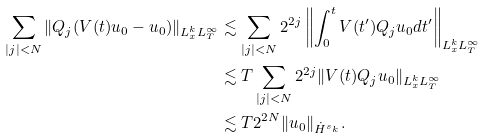<formula> <loc_0><loc_0><loc_500><loc_500>\sum _ { | j | < N } \| Q _ { j } ( V ( t ) u _ { 0 } - u _ { 0 } ) \| _ { L ^ { k } _ { x } L ^ { \infty } _ { T } } & \lesssim \sum _ { | j | < N } 2 ^ { 2 j } \left \| \int _ { 0 } ^ { t } V ( t ^ { \prime } ) Q _ { j } u _ { 0 } d t ^ { \prime } \right \| _ { L ^ { k } _ { x } L ^ { \infty } _ { T } } \\ & \lesssim T \sum _ { | j | < N } 2 ^ { 2 j } \| V ( t ) Q _ { j } u _ { 0 } \| _ { L ^ { k } _ { x } L ^ { \infty } _ { T } } \\ & \lesssim T 2 ^ { 2 N } \| u _ { 0 } \| _ { \dot { H } ^ { s _ { k } } } .</formula> 